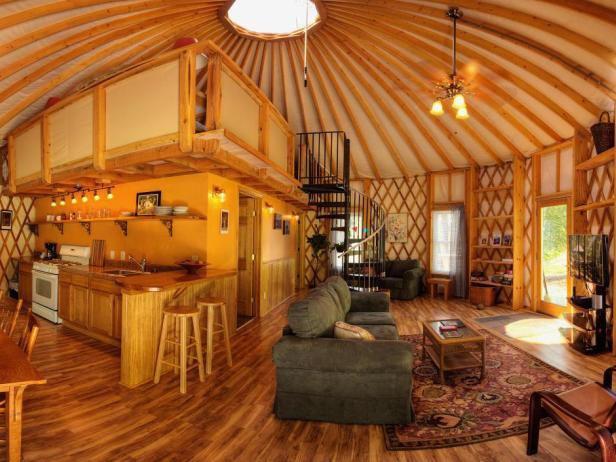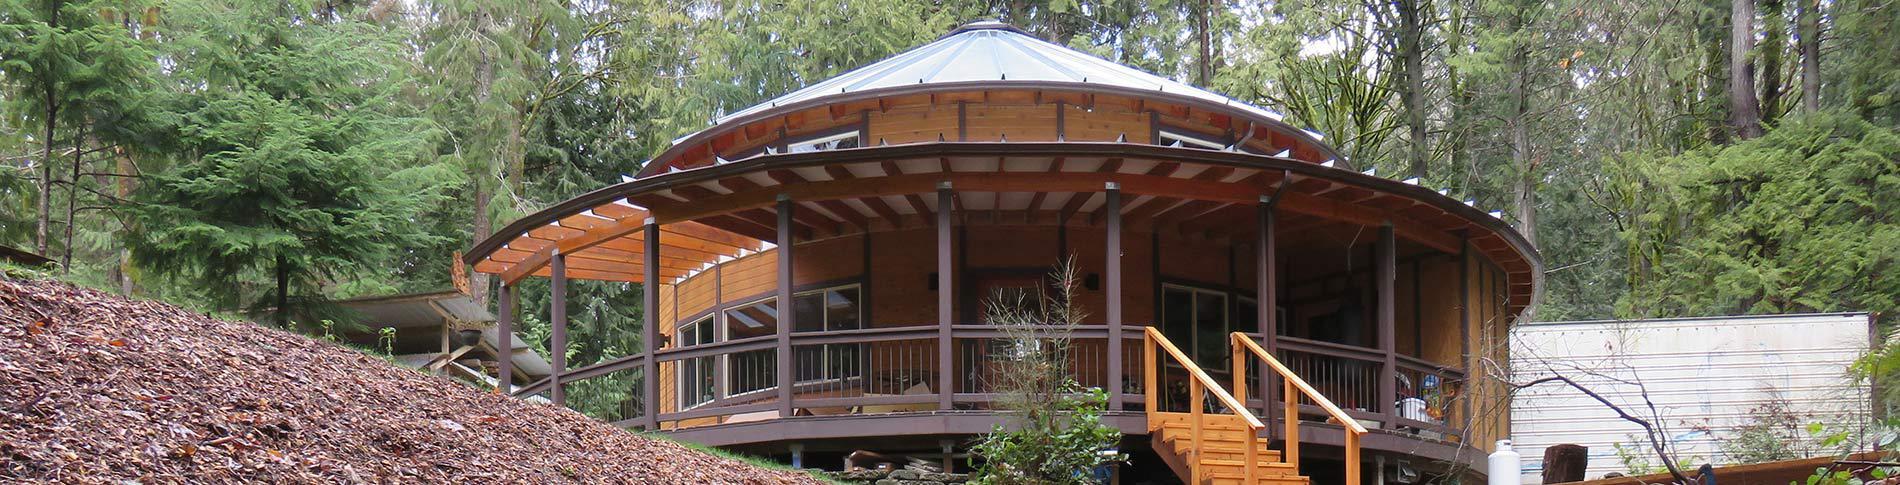The first image is the image on the left, the second image is the image on the right. Assess this claim about the two images: "The image on the right contains stairs.". Correct or not? Answer yes or no. Yes. 